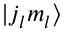<formula> <loc_0><loc_0><loc_500><loc_500>| j _ { l } m _ { l } \rangle</formula> 